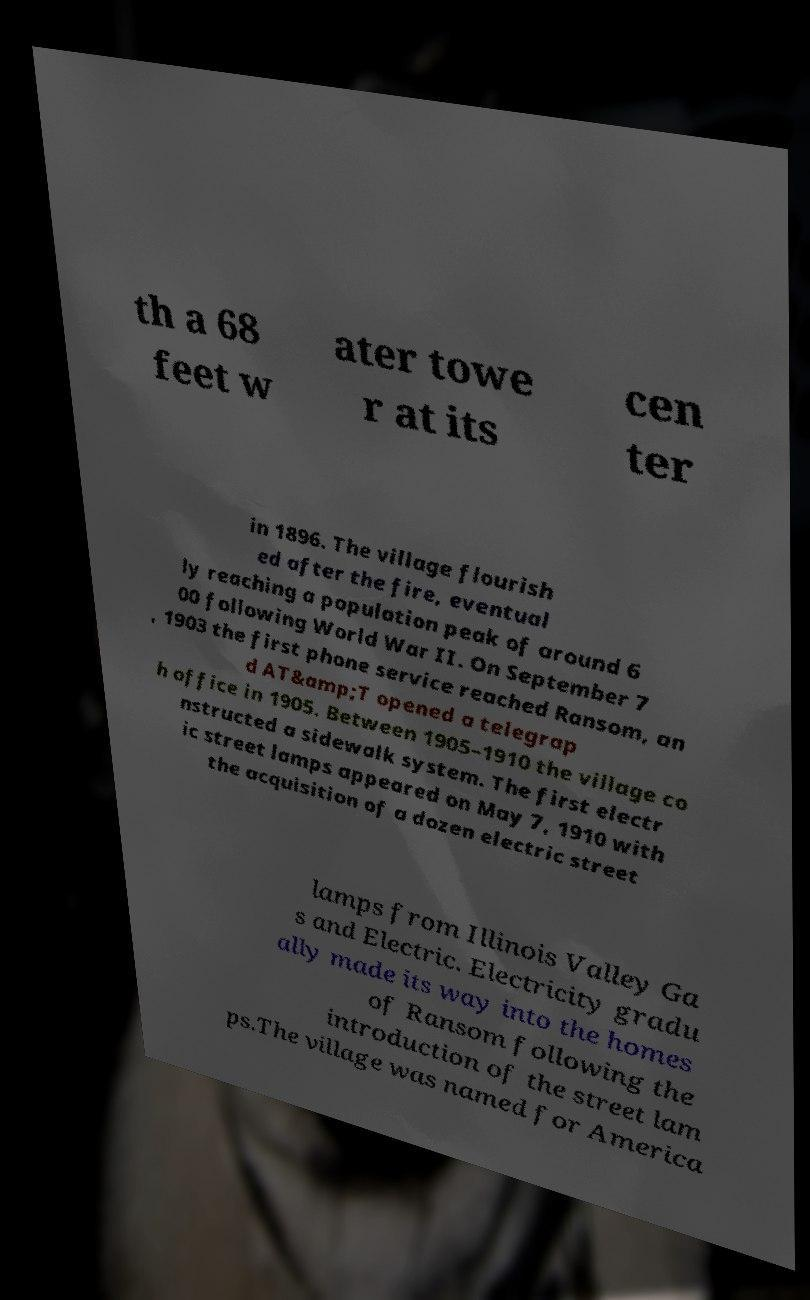Please identify and transcribe the text found in this image. th a 68 feet w ater towe r at its cen ter in 1896. The village flourish ed after the fire, eventual ly reaching a population peak of around 6 00 following World War II. On September 7 , 1903 the first phone service reached Ransom, an d AT&amp;T opened a telegrap h office in 1905. Between 1905–1910 the village co nstructed a sidewalk system. The first electr ic street lamps appeared on May 7, 1910 with the acquisition of a dozen electric street lamps from Illinois Valley Ga s and Electric. Electricity gradu ally made its way into the homes of Ransom following the introduction of the street lam ps.The village was named for America 